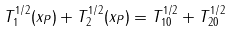Convert formula to latex. <formula><loc_0><loc_0><loc_500><loc_500>T _ { 1 } ^ { 1 / 2 } ( x _ { P } ) + T _ { 2 } ^ { 1 / 2 } ( x _ { P } ) = T _ { 1 0 } ^ { 1 / 2 } + T _ { 2 0 } ^ { 1 / 2 }</formula> 